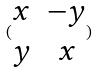Convert formula to latex. <formula><loc_0><loc_0><loc_500><loc_500>( \begin{matrix} x & - y \\ y & x \end{matrix} )</formula> 